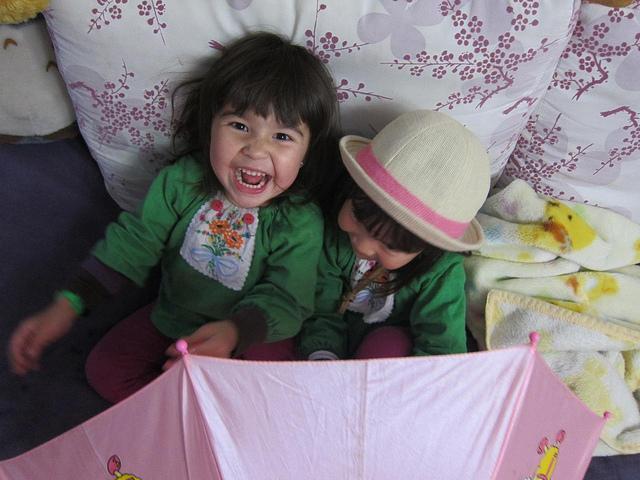How many beds are there?
Give a very brief answer. 2. How many people are there?
Give a very brief answer. 2. How many cars are in the background?
Give a very brief answer. 0. 